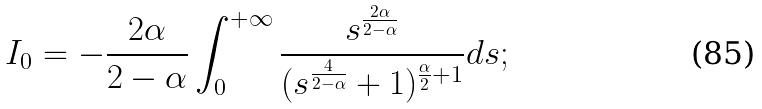<formula> <loc_0><loc_0><loc_500><loc_500>I _ { 0 } = - \frac { 2 \alpha } { 2 - \alpha } \int _ { 0 } ^ { + \infty } \frac { s ^ { \frac { 2 \alpha } { 2 - \alpha } } } { ( s ^ { \frac { 4 } { 2 - \alpha } } + 1 ) ^ { \frac { \alpha } { 2 } + 1 } } d s ;</formula> 